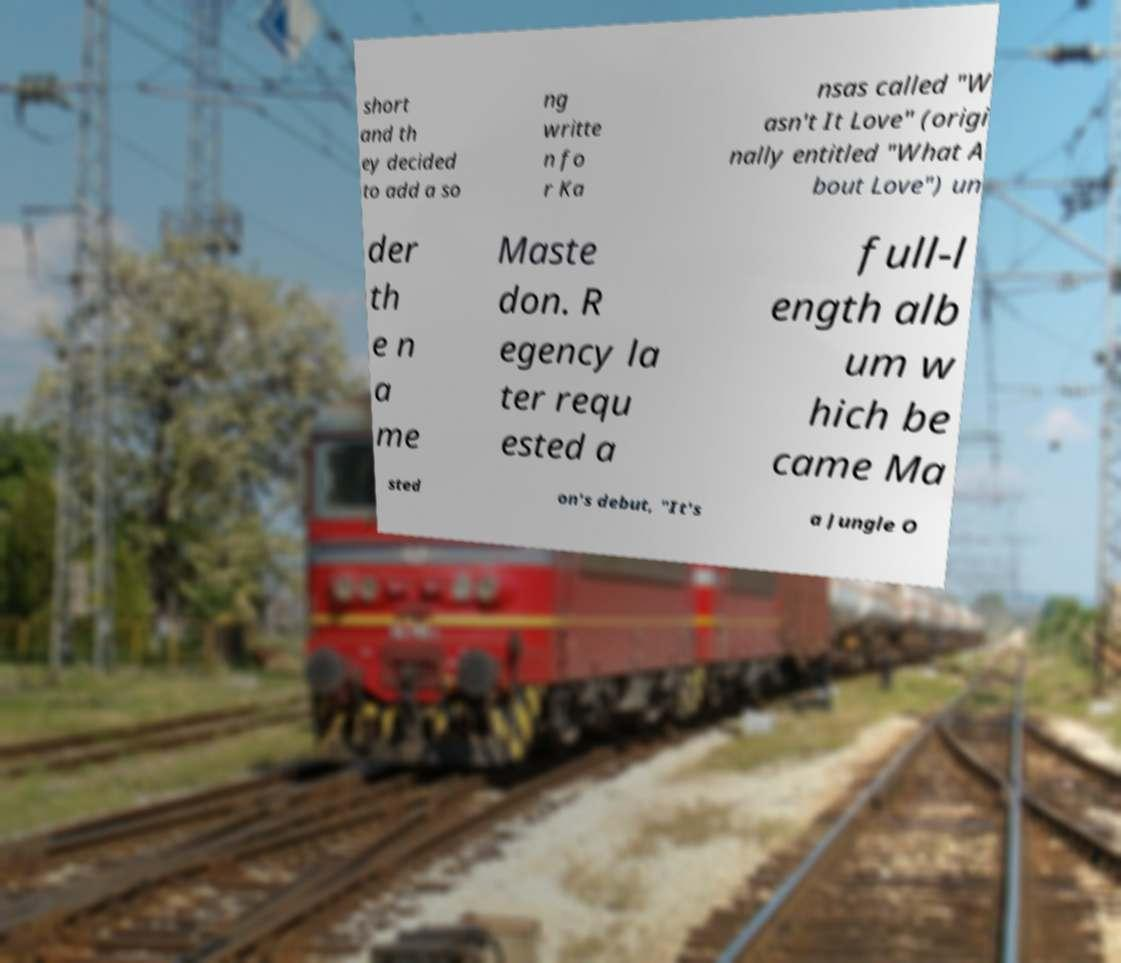There's text embedded in this image that I need extracted. Can you transcribe it verbatim? short and th ey decided to add a so ng writte n fo r Ka nsas called "W asn't It Love" (origi nally entitled "What A bout Love") un der th e n a me Maste don. R egency la ter requ ested a full-l ength alb um w hich be came Ma sted on's debut, "It's a Jungle O 